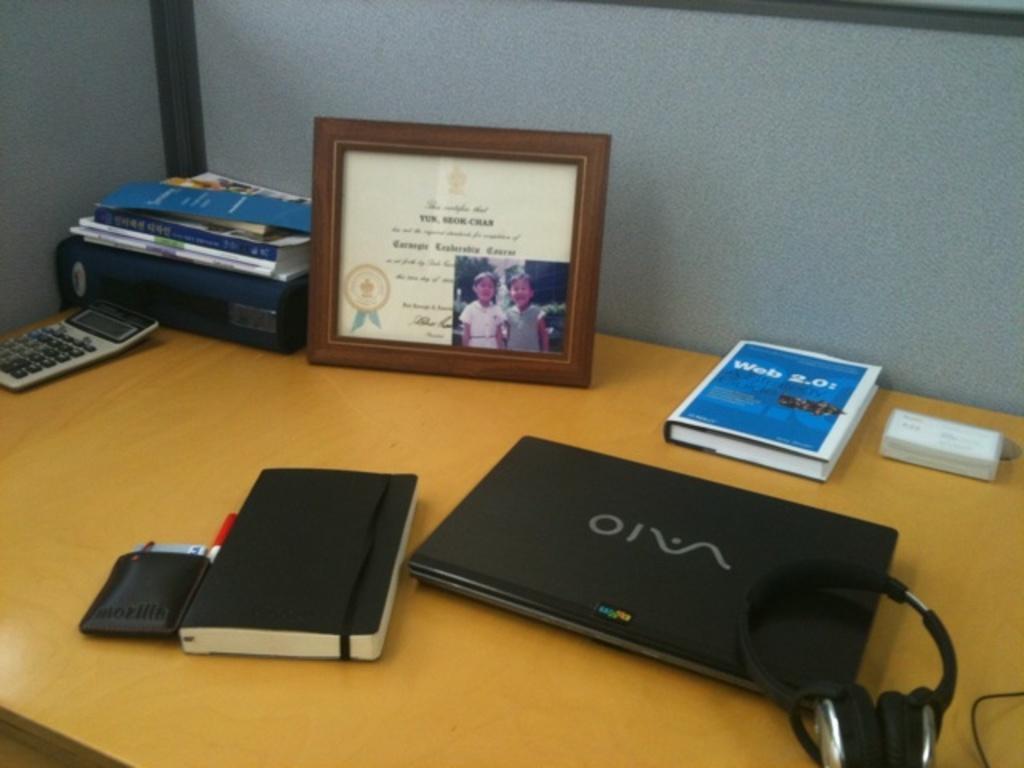Please provide a concise description of this image. In this picture we can see laptop, book, wallet, calculator, shield and headphones. 